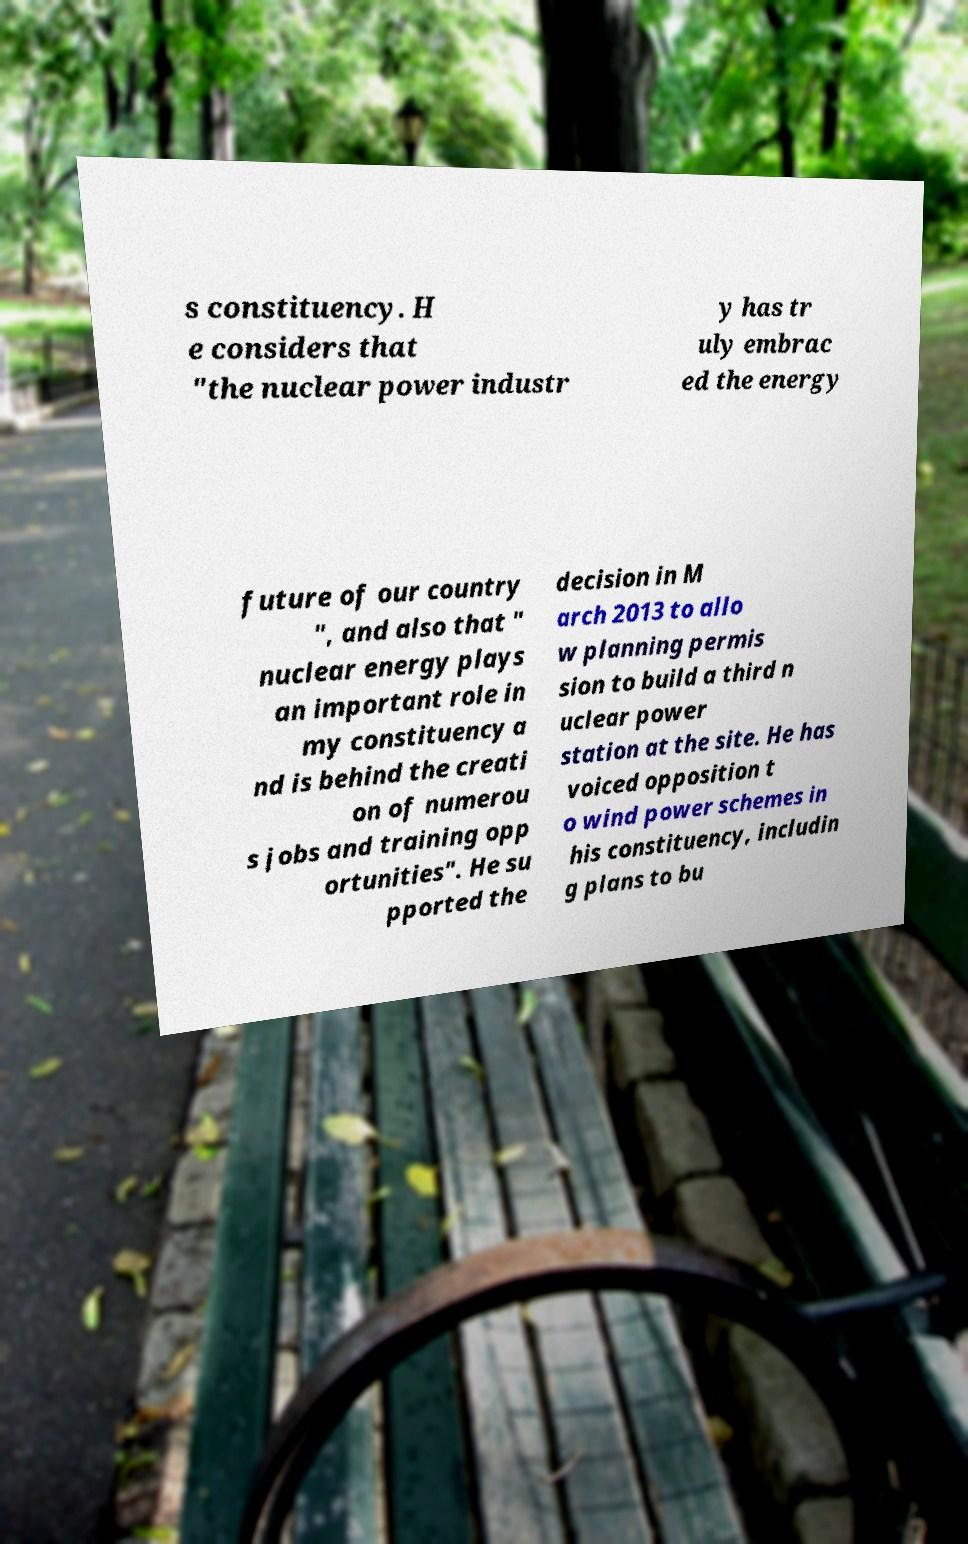Can you read and provide the text displayed in the image?This photo seems to have some interesting text. Can you extract and type it out for me? s constituency. H e considers that "the nuclear power industr y has tr uly embrac ed the energy future of our country ", and also that " nuclear energy plays an important role in my constituency a nd is behind the creati on of numerou s jobs and training opp ortunities". He su pported the decision in M arch 2013 to allo w planning permis sion to build a third n uclear power station at the site. He has voiced opposition t o wind power schemes in his constituency, includin g plans to bu 